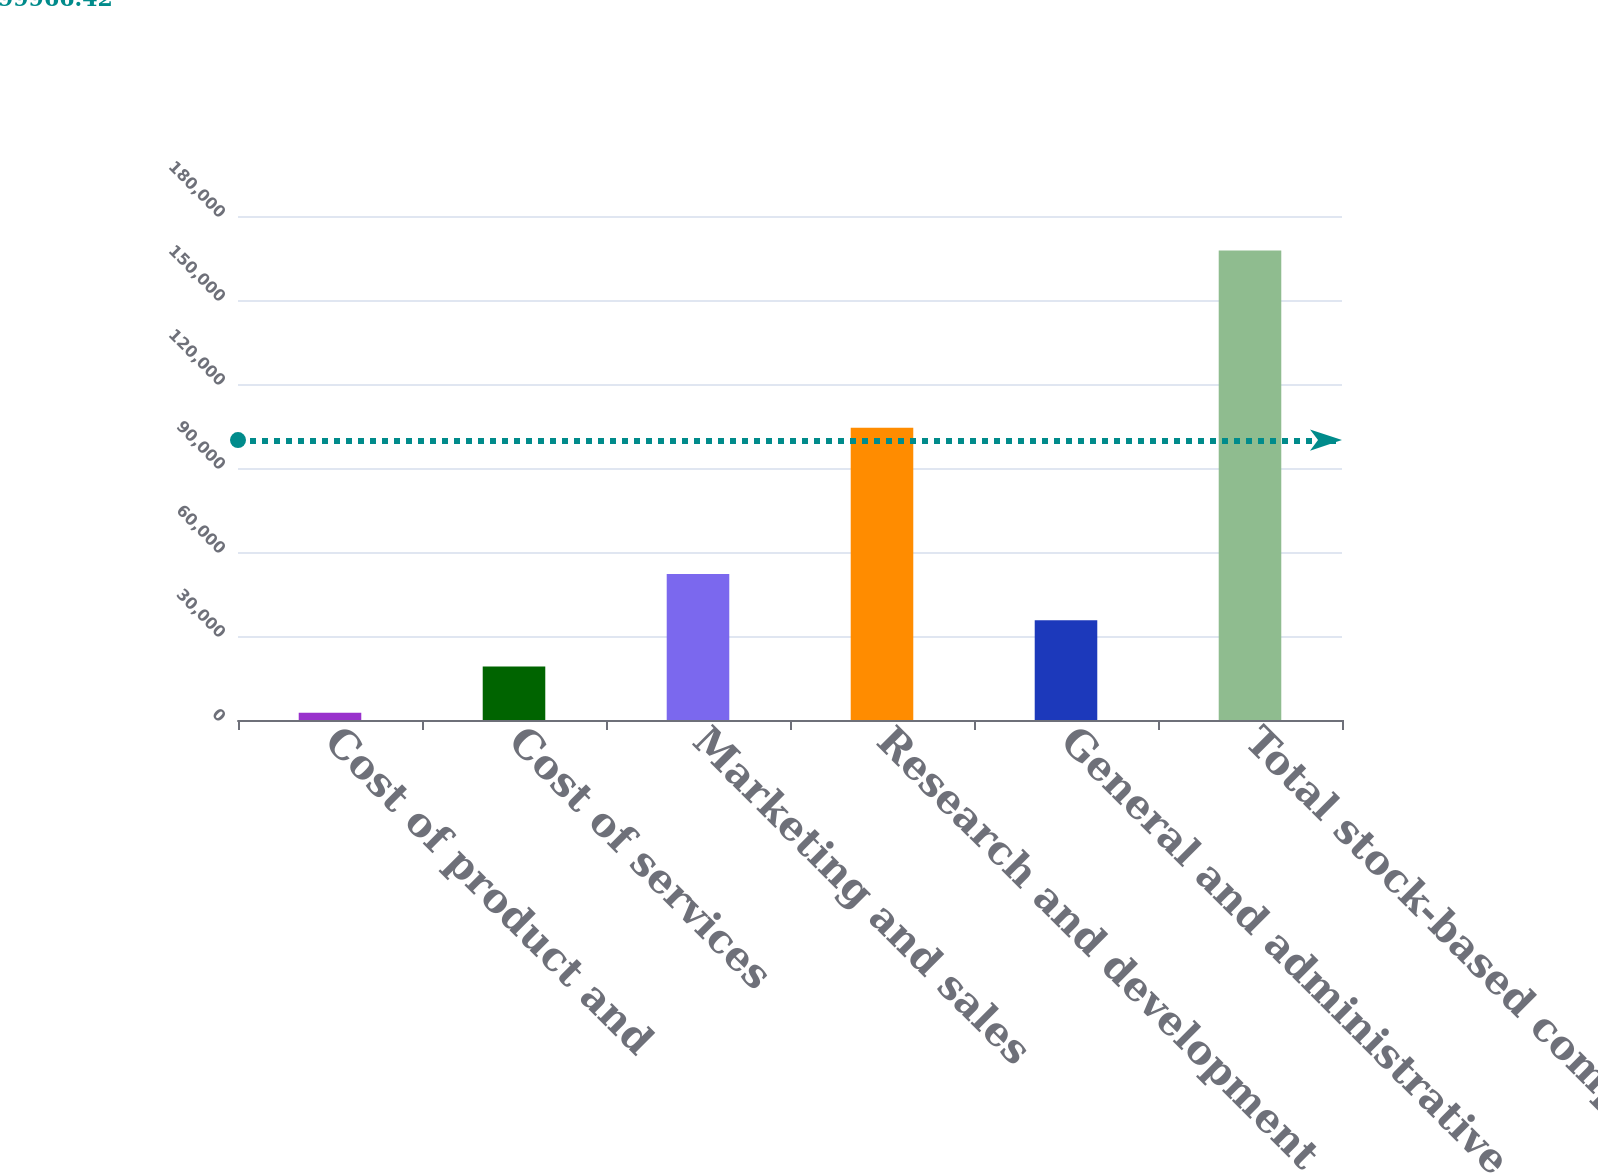Convert chart. <chart><loc_0><loc_0><loc_500><loc_500><bar_chart><fcel>Cost of product and<fcel>Cost of services<fcel>Marketing and sales<fcel>Research and development<fcel>General and administrative<fcel>Total stock-based compensation<nl><fcel>2631<fcel>19139.4<fcel>52156.2<fcel>104353<fcel>35647.8<fcel>167715<nl></chart> 